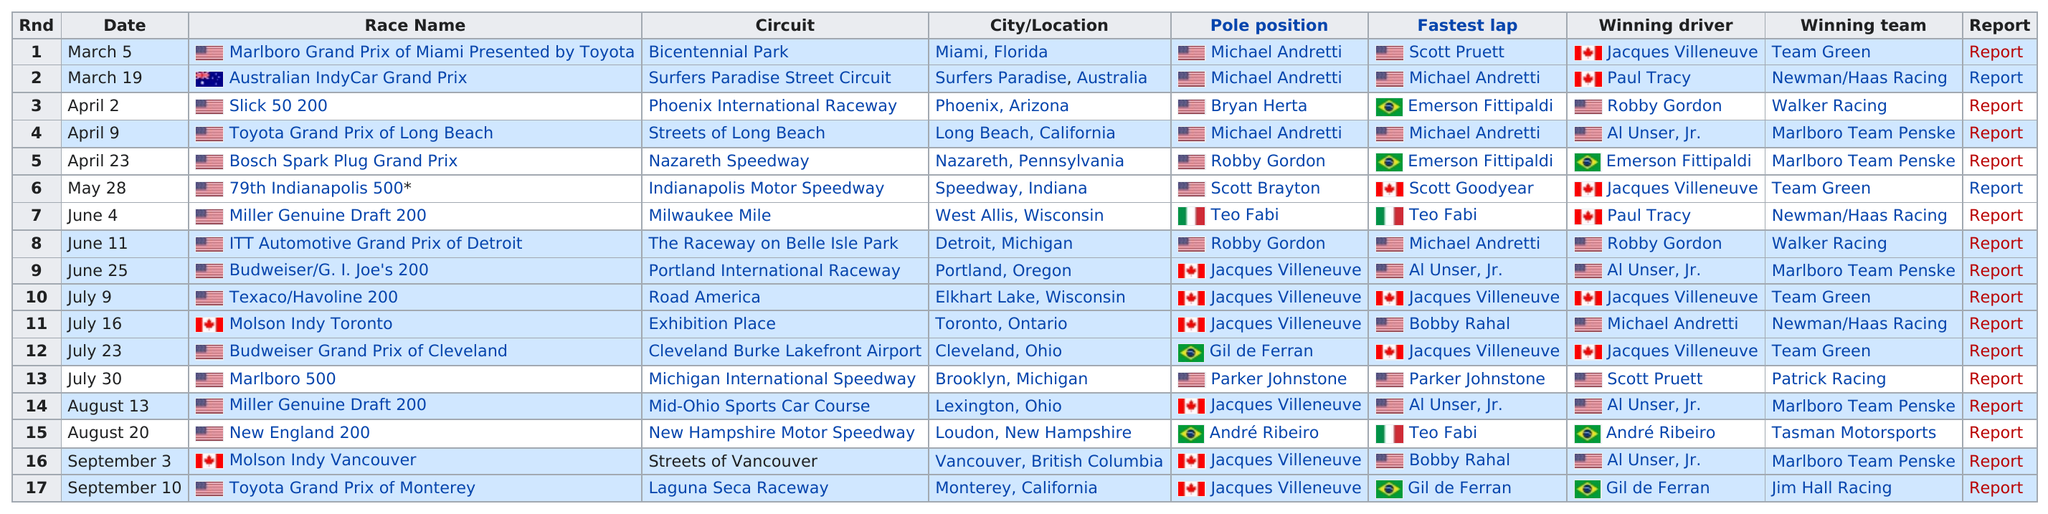Highlight a few significant elements in this photo. Michael Andretti held the pole position for three races. On March 5, the race took place in Miami, Florida, and the next race took place in Surfers Paradise, Australia. After the race at Nazareth Speedway, the next event on the schedule was the Indianapolis Motor Speedway. The Marlboro Grand Prix of Miami Presented by Toyota was the first race. The Toyota Grand Prix of Long Beach was followed by the race of a particular race that is known as the Toyota Grand Prix of Long Beach. 